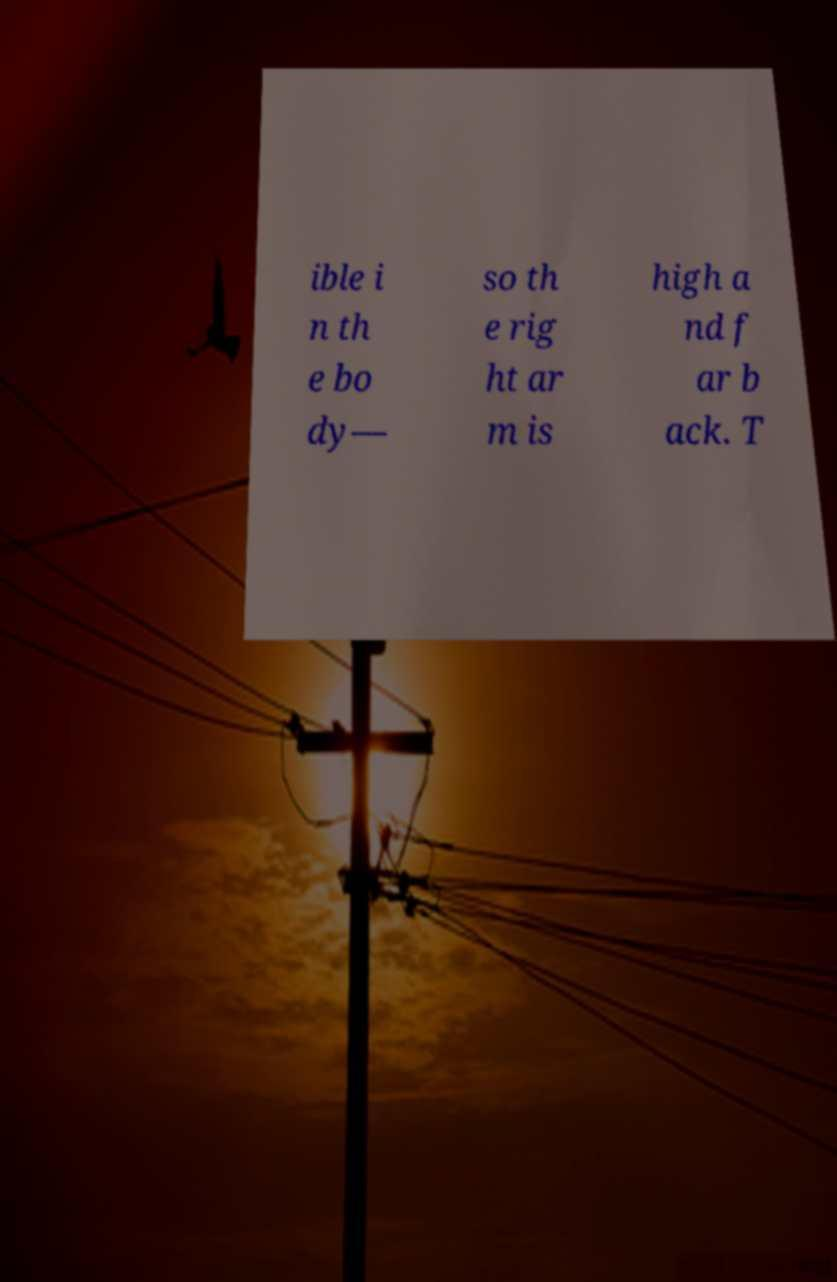Can you accurately transcribe the text from the provided image for me? ible i n th e bo dy— so th e rig ht ar m is high a nd f ar b ack. T 